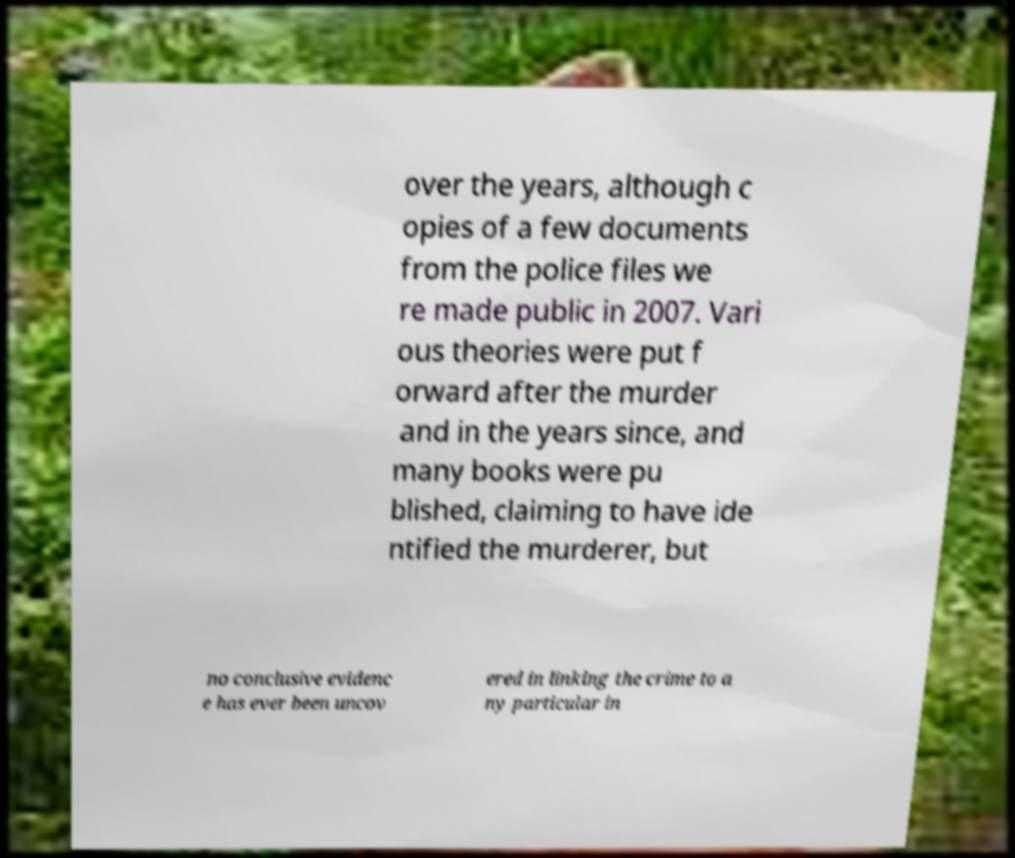Please identify and transcribe the text found in this image. over the years, although c opies of a few documents from the police files we re made public in 2007. Vari ous theories were put f orward after the murder and in the years since, and many books were pu blished, claiming to have ide ntified the murderer, but no conclusive evidenc e has ever been uncov ered in linking the crime to a ny particular in 